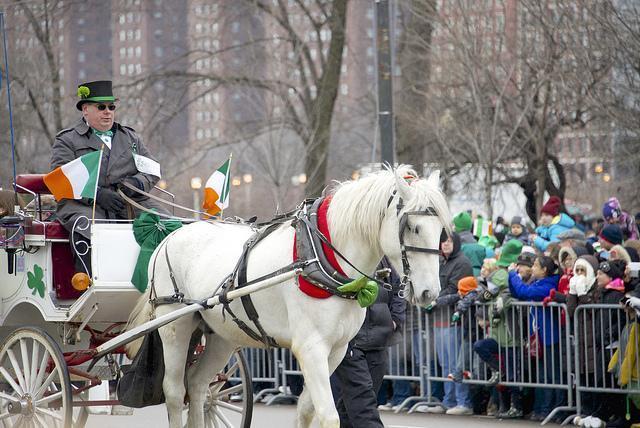How many horses are there?
Give a very brief answer. 1. How many horses are pictured?
Give a very brief answer. 1. How many people can be seen?
Give a very brief answer. 4. How many oranges are there?
Give a very brief answer. 0. 